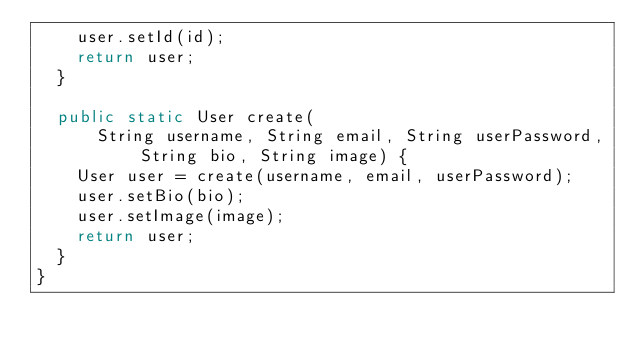<code> <loc_0><loc_0><loc_500><loc_500><_Java_>    user.setId(id);
    return user;
  }

  public static User create(
      String username, String email, String userPassword, String bio, String image) {
    User user = create(username, email, userPassword);
    user.setBio(bio);
    user.setImage(image);
    return user;
  }
}
</code> 